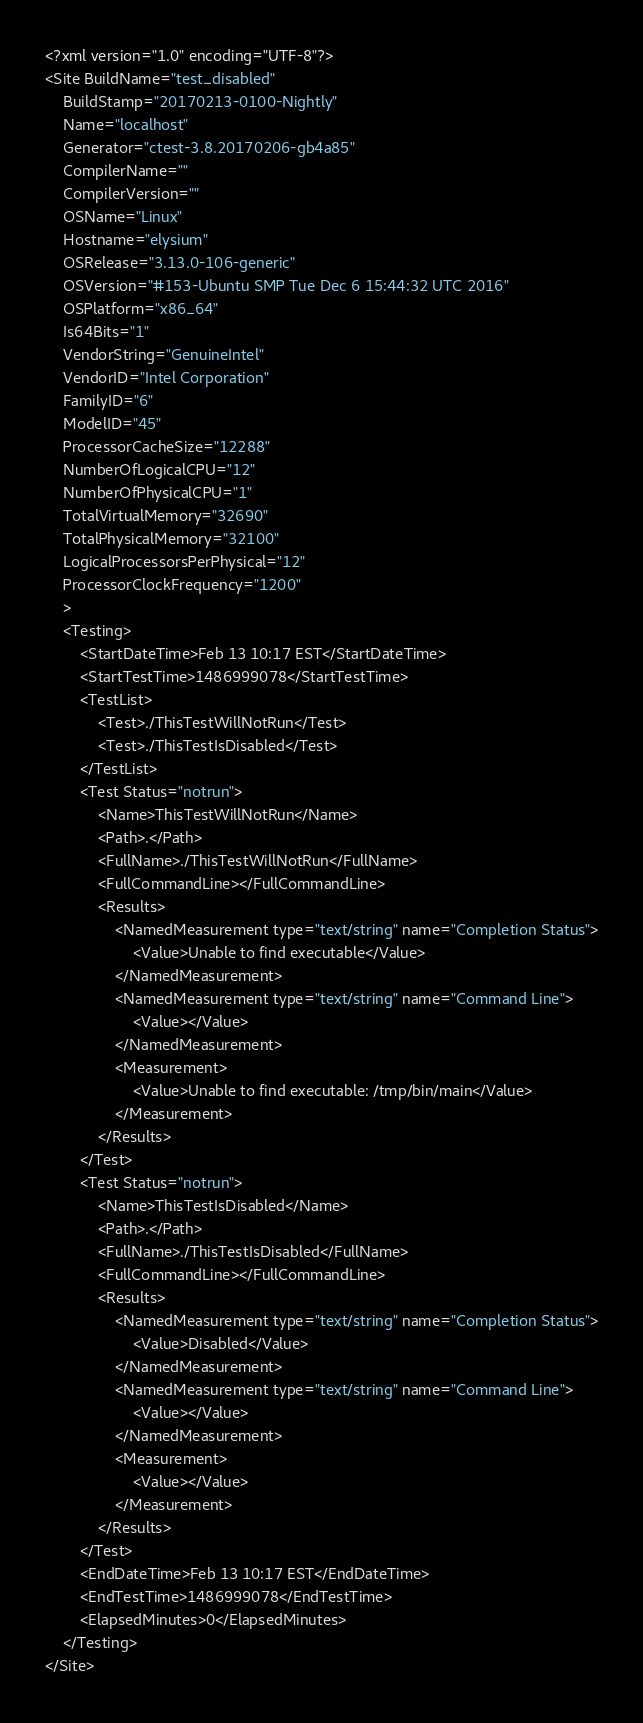Convert code to text. <code><loc_0><loc_0><loc_500><loc_500><_XML_><?xml version="1.0" encoding="UTF-8"?>
<Site BuildName="test_disabled"
	BuildStamp="20170213-0100-Nightly"
	Name="localhost"
	Generator="ctest-3.8.20170206-gb4a85"
	CompilerName=""
	CompilerVersion=""
	OSName="Linux"
	Hostname="elysium"
	OSRelease="3.13.0-106-generic"
	OSVersion="#153-Ubuntu SMP Tue Dec 6 15:44:32 UTC 2016"
	OSPlatform="x86_64"
	Is64Bits="1"
	VendorString="GenuineIntel"
	VendorID="Intel Corporation"
	FamilyID="6"
	ModelID="45"
	ProcessorCacheSize="12288"
	NumberOfLogicalCPU="12"
	NumberOfPhysicalCPU="1"
	TotalVirtualMemory="32690"
	TotalPhysicalMemory="32100"
	LogicalProcessorsPerPhysical="12"
	ProcessorClockFrequency="1200"
	>
	<Testing>
		<StartDateTime>Feb 13 10:17 EST</StartDateTime>
		<StartTestTime>1486999078</StartTestTime>
		<TestList>
			<Test>./ThisTestWillNotRun</Test>
			<Test>./ThisTestIsDisabled</Test>
		</TestList>
		<Test Status="notrun">
			<Name>ThisTestWillNotRun</Name>
			<Path>.</Path>
			<FullName>./ThisTestWillNotRun</FullName>
			<FullCommandLine></FullCommandLine>
			<Results>
				<NamedMeasurement type="text/string" name="Completion Status">
					<Value>Unable to find executable</Value>
				</NamedMeasurement>
				<NamedMeasurement type="text/string" name="Command Line">
					<Value></Value>
				</NamedMeasurement>
				<Measurement>
					<Value>Unable to find executable: /tmp/bin/main</Value>
				</Measurement>
			</Results>
		</Test>
		<Test Status="notrun">
			<Name>ThisTestIsDisabled</Name>
			<Path>.</Path>
			<FullName>./ThisTestIsDisabled</FullName>
			<FullCommandLine></FullCommandLine>
			<Results>
				<NamedMeasurement type="text/string" name="Completion Status">
					<Value>Disabled</Value>
				</NamedMeasurement>
				<NamedMeasurement type="text/string" name="Command Line">
					<Value></Value>
				</NamedMeasurement>
				<Measurement>
					<Value></Value>
				</Measurement>
			</Results>
		</Test>
		<EndDateTime>Feb 13 10:17 EST</EndDateTime>
		<EndTestTime>1486999078</EndTestTime>
		<ElapsedMinutes>0</ElapsedMinutes>
	</Testing>
</Site>
</code> 